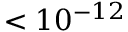Convert formula to latex. <formula><loc_0><loc_0><loc_500><loc_500>< 1 0 ^ { - 1 2 }</formula> 